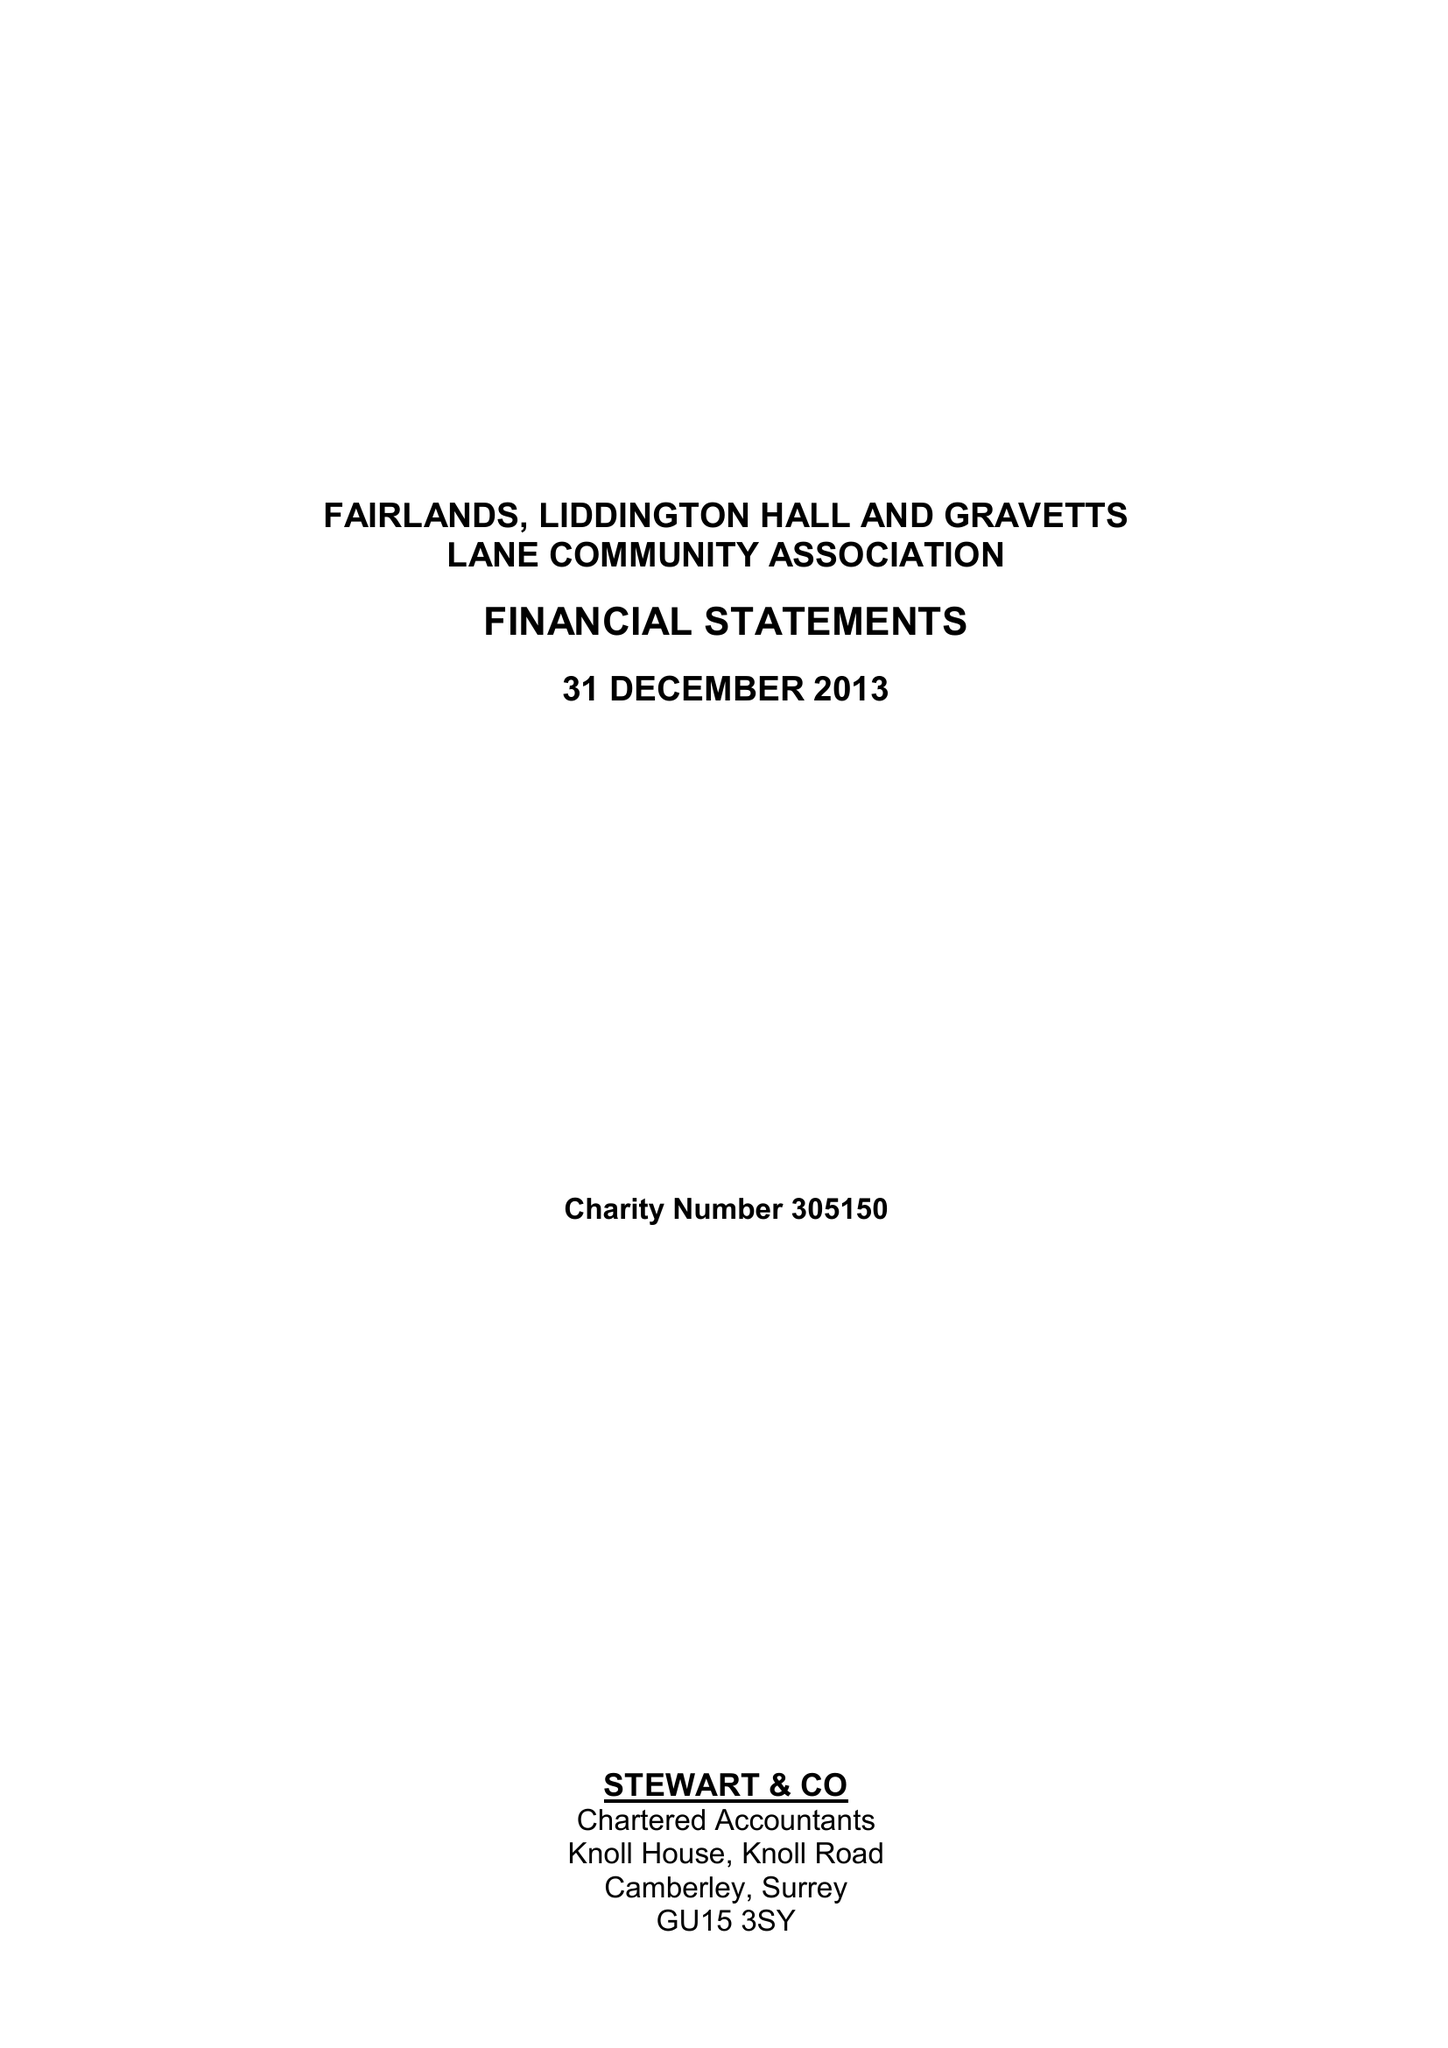What is the value for the income_annually_in_british_pounds?
Answer the question using a single word or phrase. 38755.00 